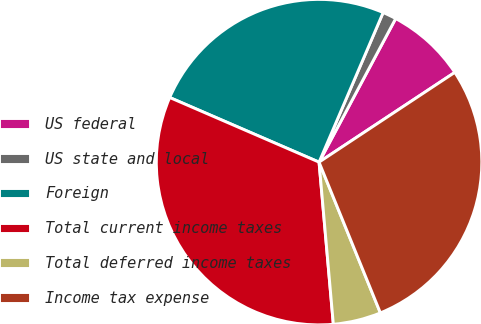Convert chart. <chart><loc_0><loc_0><loc_500><loc_500><pie_chart><fcel>US federal<fcel>US state and local<fcel>Foreign<fcel>Total current income taxes<fcel>Total deferred income taxes<fcel>Income tax expense<nl><fcel>7.9%<fcel>1.36%<fcel>24.94%<fcel>32.9%<fcel>4.75%<fcel>28.15%<nl></chart> 